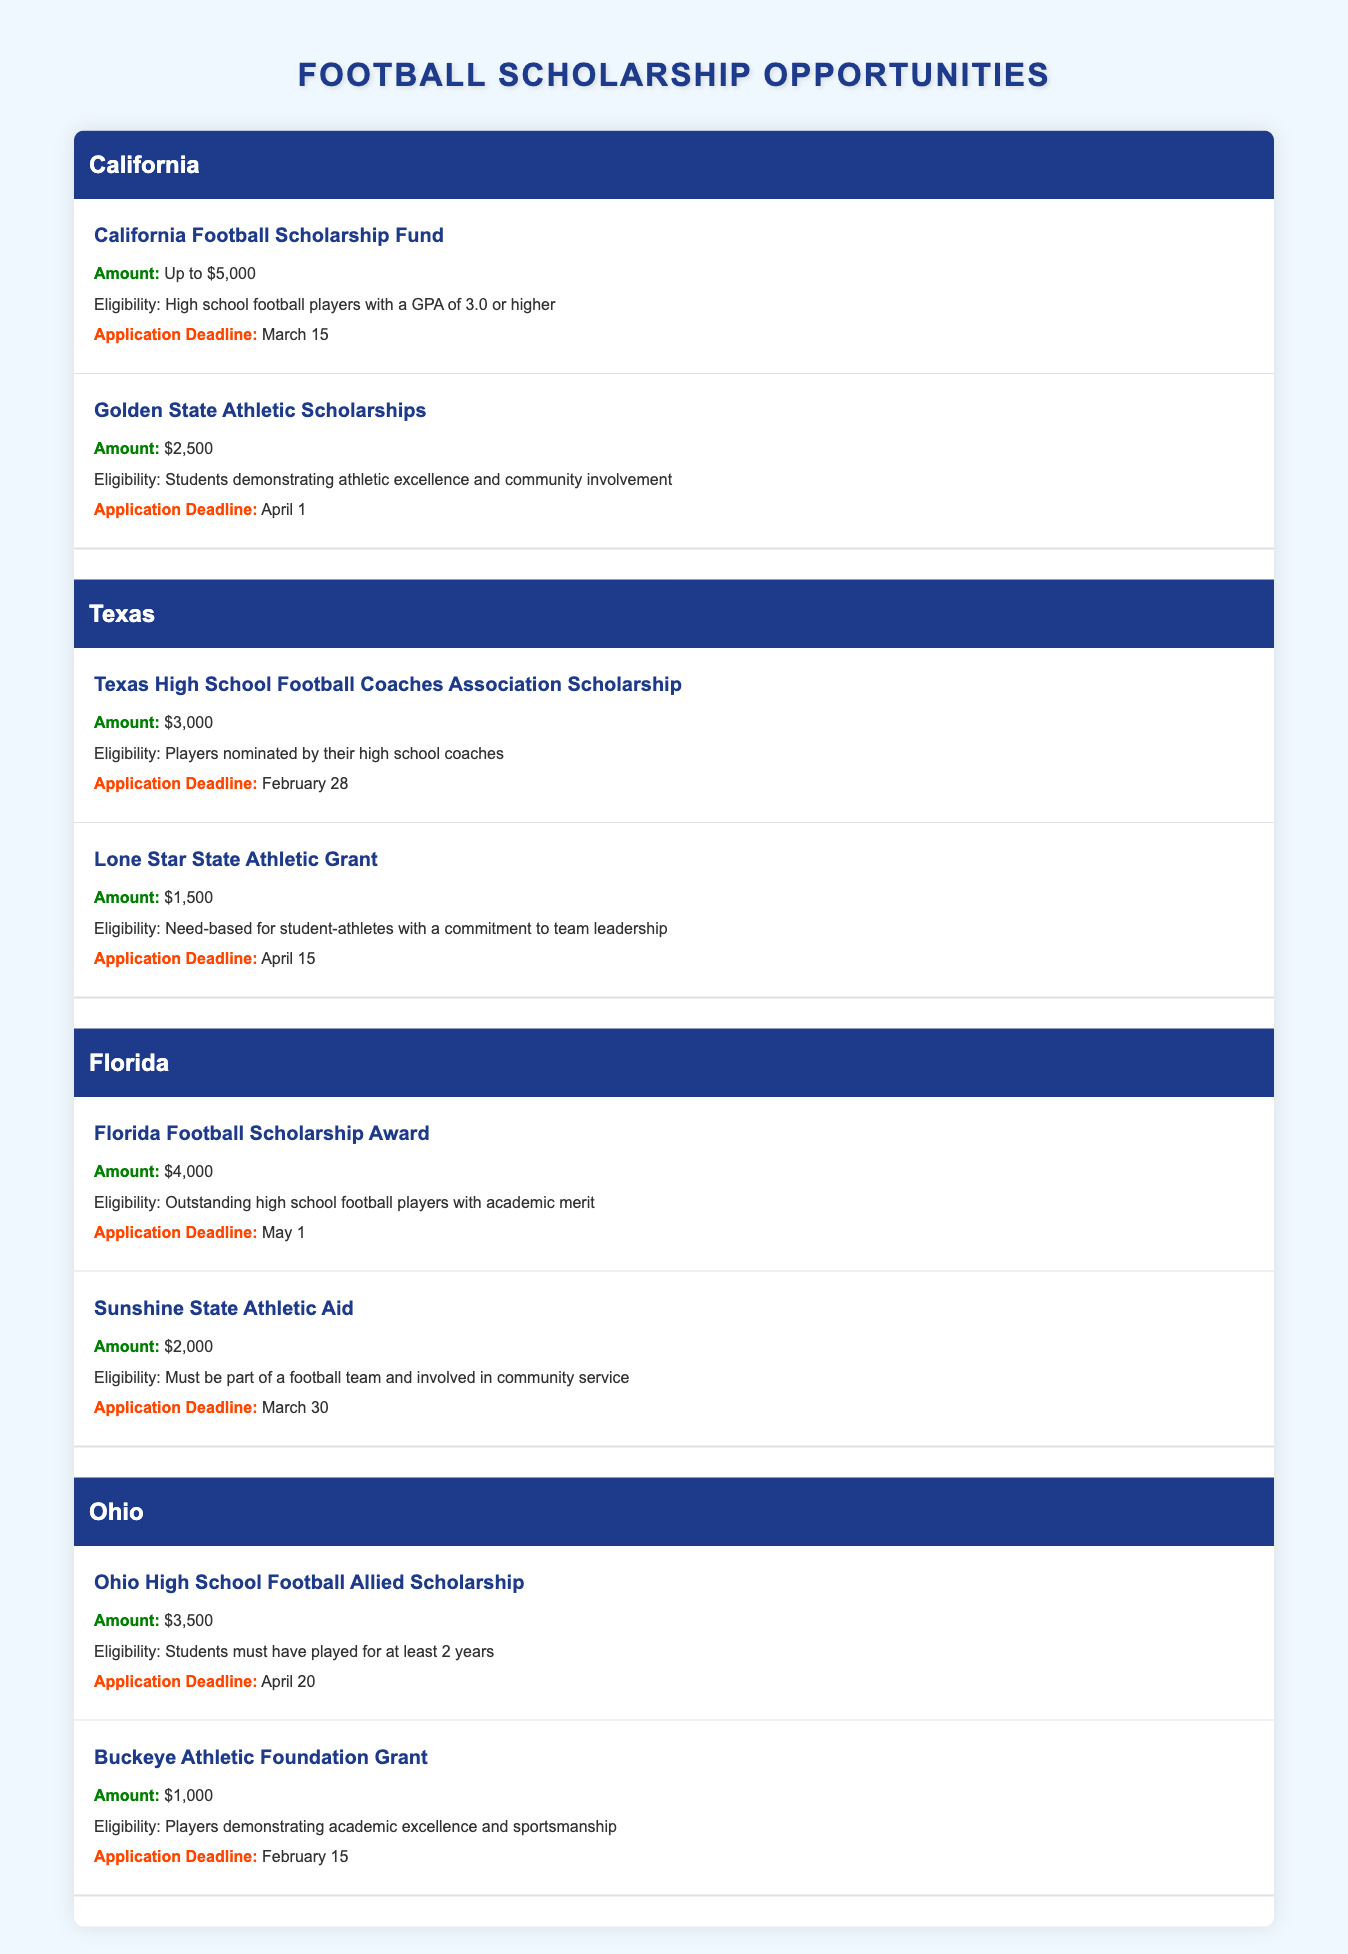What is the amount of the California Football Scholarship Fund? The table indicates that the amount offered by the California Football Scholarship Fund is "Up to $5,000."
Answer: Up to $5,000 Which state offers a scholarship for players nominated by their high school coaches? The table shows that the "Texas High School Football Coaches Association Scholarship" requires players to be nominated by their high school coaches, and this scholarship is listed under Texas.
Answer: Texas What is the application deadline for the Ohio High School Football Allied Scholarship? The table mentions that the application deadline for the Ohio High School Football Allied Scholarship is April 20.
Answer: April 20 Which Florida scholarship has an application deadline of May 1? According to the table, the "Florida Football Scholarship Award" has an application deadline of May 1.
Answer: Florida Football Scholarship Award Is the Buckeye Athletic Foundation Grant available for players who have shown academic excellence? Yes, the table states that the Buckeye Athletic Foundation Grant is for players demonstrating academic excellence and sportsmanship, which indicates eligibility based on academic performance.
Answer: Yes How many scholarships are available in Texas, and what is the total potential amount? Texas has two scholarships listed: "Texas High School Football Coaches Association Scholarship" offers $3,000, and "Lone Star State Athletic Grant" offers $1,500. Summing these gives 3,000 + 1,500 = 4,500, thus there are two scholarships available in Texas with a total amount of $4,500.
Answer: 2 scholarships, $4,500 What is the average scholarship amount available for high school football players in California? California has two scholarships: "California Football Scholarship Fund" (up to $5,000, treated as 5,000 for averaging) and "Golden State Athletic Scholarships" ($2,500). The sum of these amounts is 5,000 + 2,500 = 7,500. There are 2 scholarships, so the average is 7,500 / 2 = 3,750.
Answer: $3,750 Which state has the highest single scholarship amount, and what is that amount? Looking through all the states listed, the "California Football Scholarship Fund" offers "Up to $5,000," which is the highest amount compared to other scholarships in Florida ($4,000), Texas ($3,000), and Ohio ($3,500).
Answer: California, Up to $5,000 Are any scholarships specifically aimed at students involved in community service? Yes, the "Sunshine State Athletic Aid" in Florida specifically states that eligibility requires the applicant to be involved in community service alongside being part of a football team.
Answer: Yes 